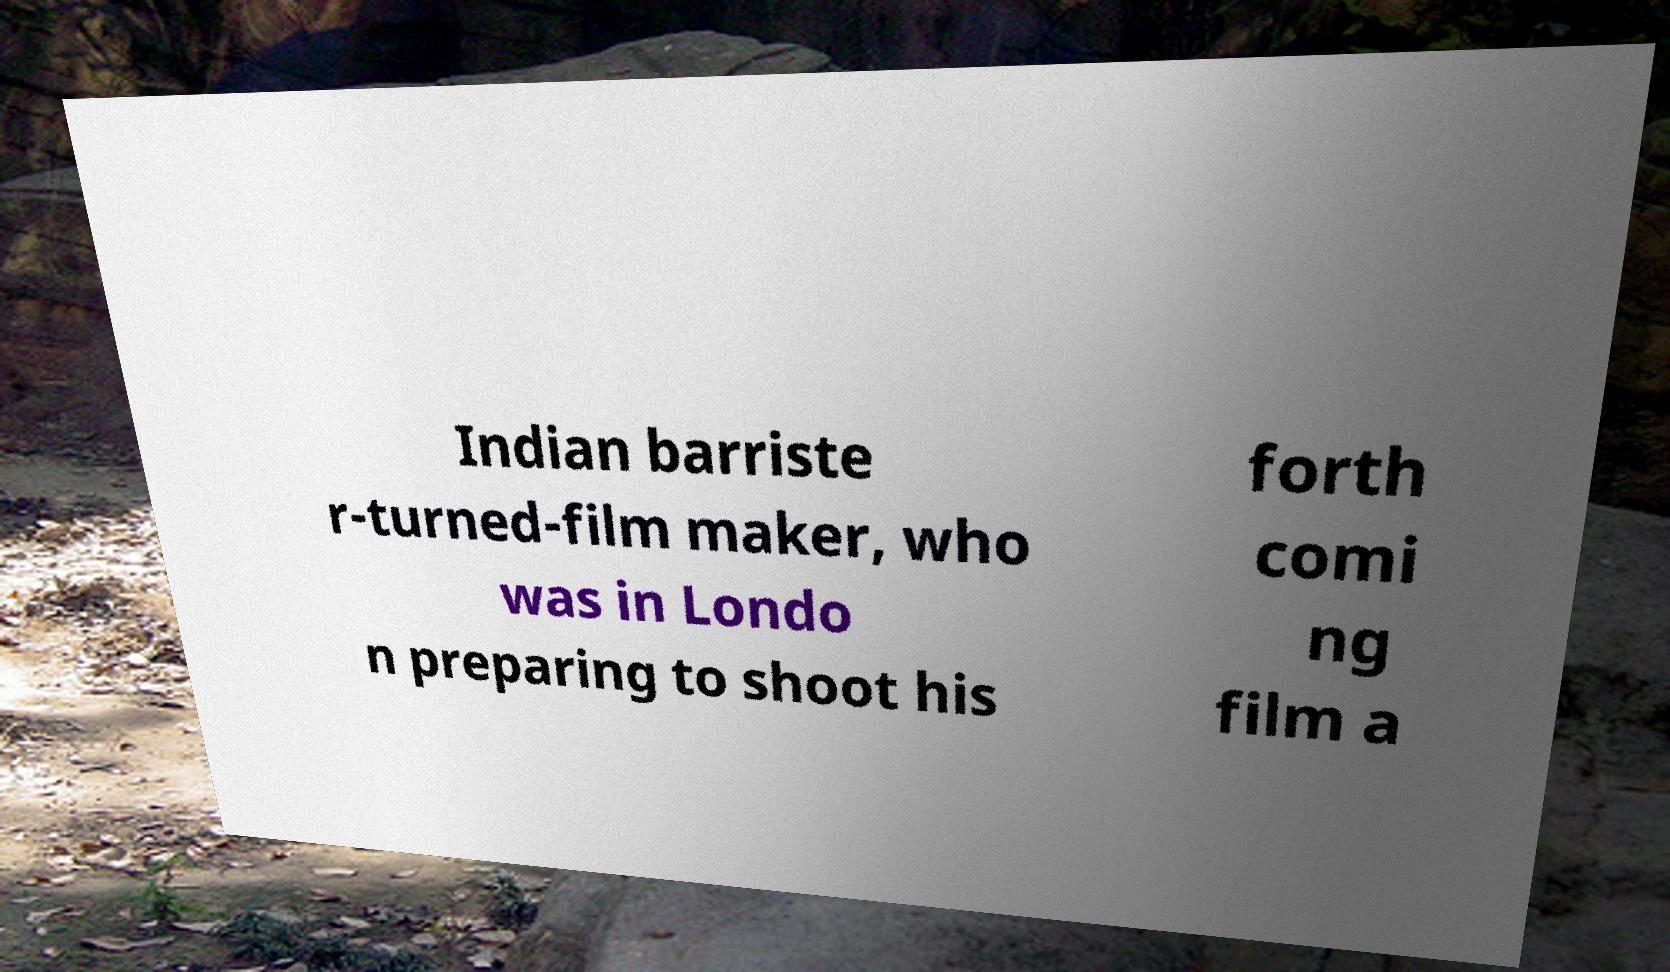I need the written content from this picture converted into text. Can you do that? Indian barriste r-turned-film maker, who was in Londo n preparing to shoot his forth comi ng film a 